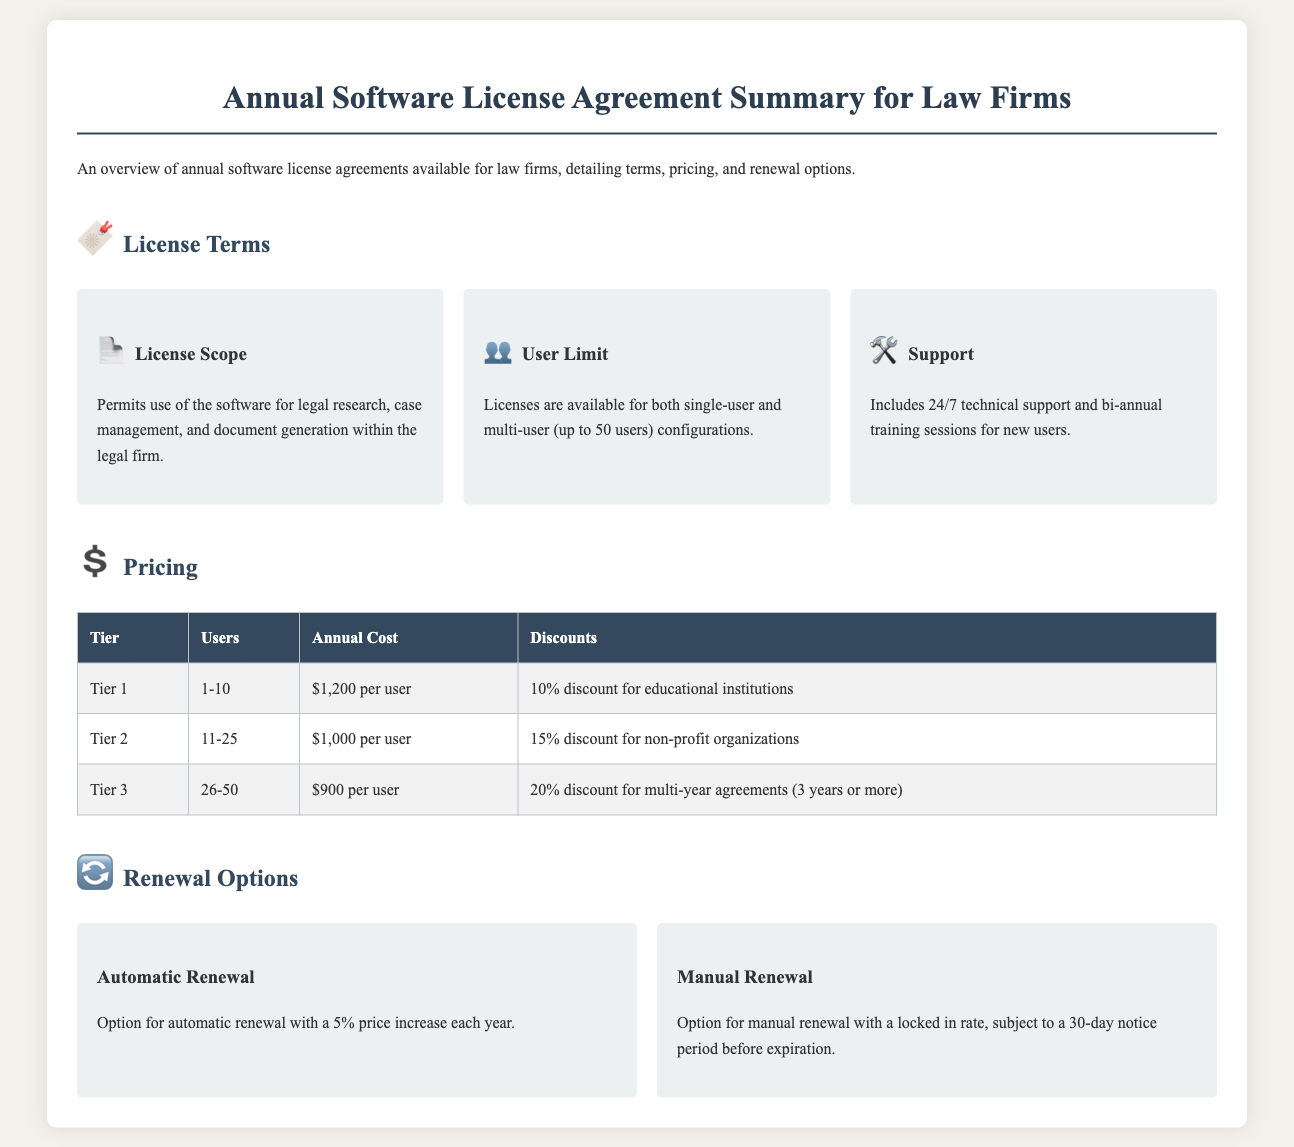What is the maximum number of users allowed in a multi-user configuration? The document states that the maximum number of users allowed is up to 50 users in a multi-user configuration.
Answer: 50 users What is the annual cost for Tier 2? Under the Pricing section, Tier 2 specifies an annual cost of $1,000 per user.
Answer: $1,000 per user What discount is available for educational institutions? The pricing table indicates a 10% discount for educational institutions.
Answer: 10% What is the option for renewal that includes a price increase? The document mentions an option for automatic renewal with a price increase.
Answer: Automatic Renewal How often are training sessions provided? The License Terms section mentions that bi-annual training sessions are provided for new users.
Answer: Bi-annual What is the notice period required for manual renewal? The document specifies a notice period of 30 days before expiration for manual renewal.
Answer: 30 days Which tier offers the lowest annual cost per user? Looking at the pricing details, Tier 3 offers the lowest annual cost at $900 per user.
Answer: Tier 3 What type of support is included with the license? The License Terms emphasize that 24/7 technical support is included.
Answer: 24/7 technical support 